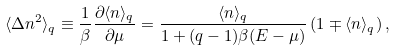Convert formula to latex. <formula><loc_0><loc_0><loc_500><loc_500>\langle \Delta n ^ { 2 } \rangle _ { q } \equiv \frac { 1 } { \beta } \frac { \partial \langle n \rangle _ { q } } { \partial \mu } = \frac { \langle n \rangle _ { q } } { 1 + ( q - 1 ) \beta ( E - \mu ) } \, ( 1 \mp \langle n \rangle _ { q } ) \, ,</formula> 